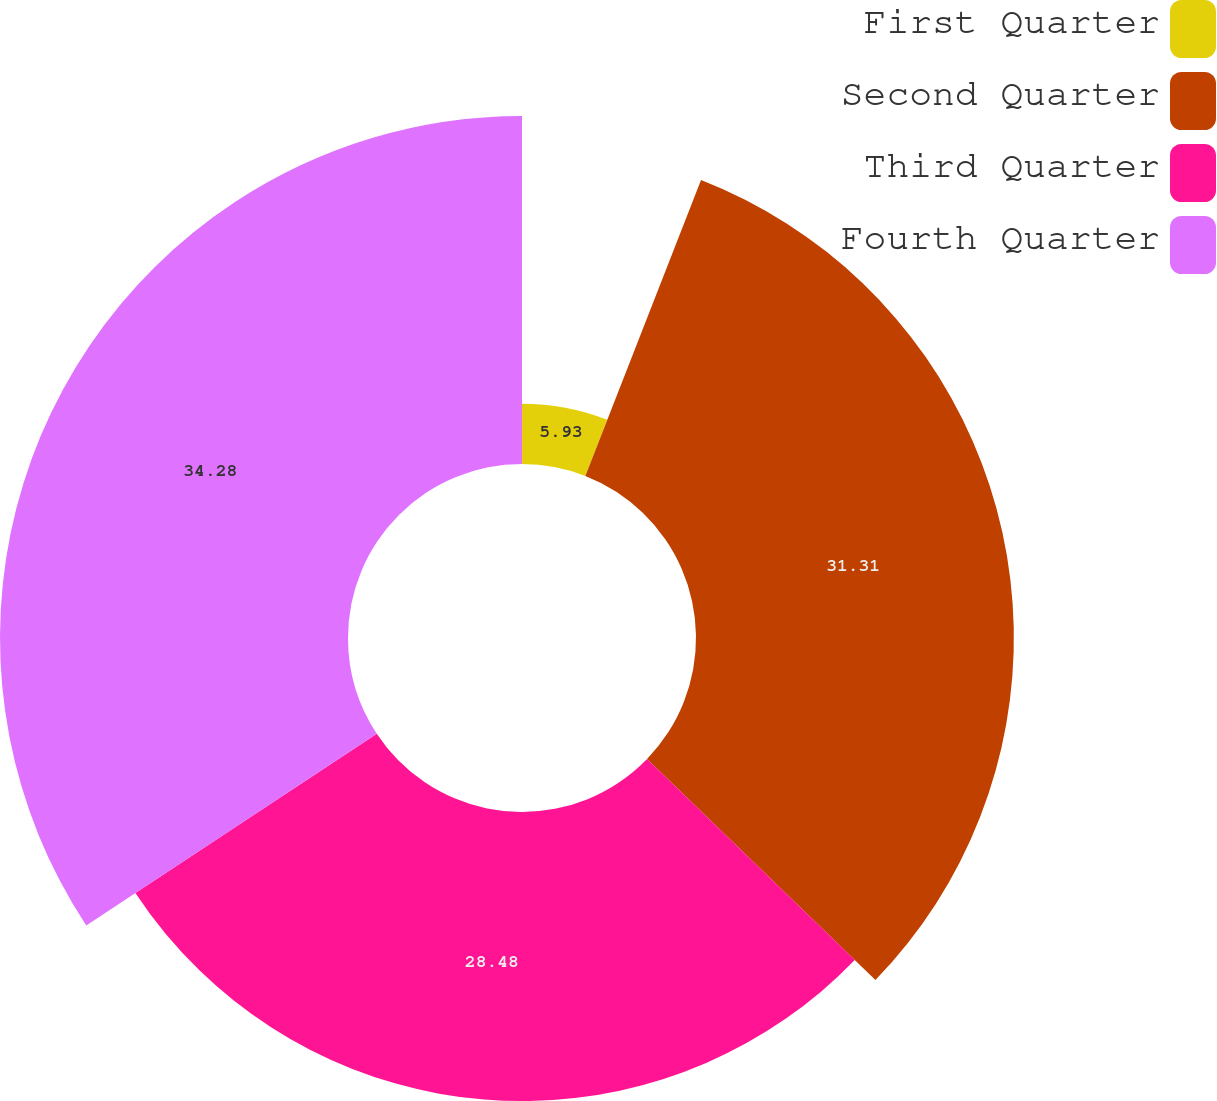Convert chart. <chart><loc_0><loc_0><loc_500><loc_500><pie_chart><fcel>First Quarter<fcel>Second Quarter<fcel>Third Quarter<fcel>Fourth Quarter<nl><fcel>5.93%<fcel>31.31%<fcel>28.48%<fcel>34.28%<nl></chart> 